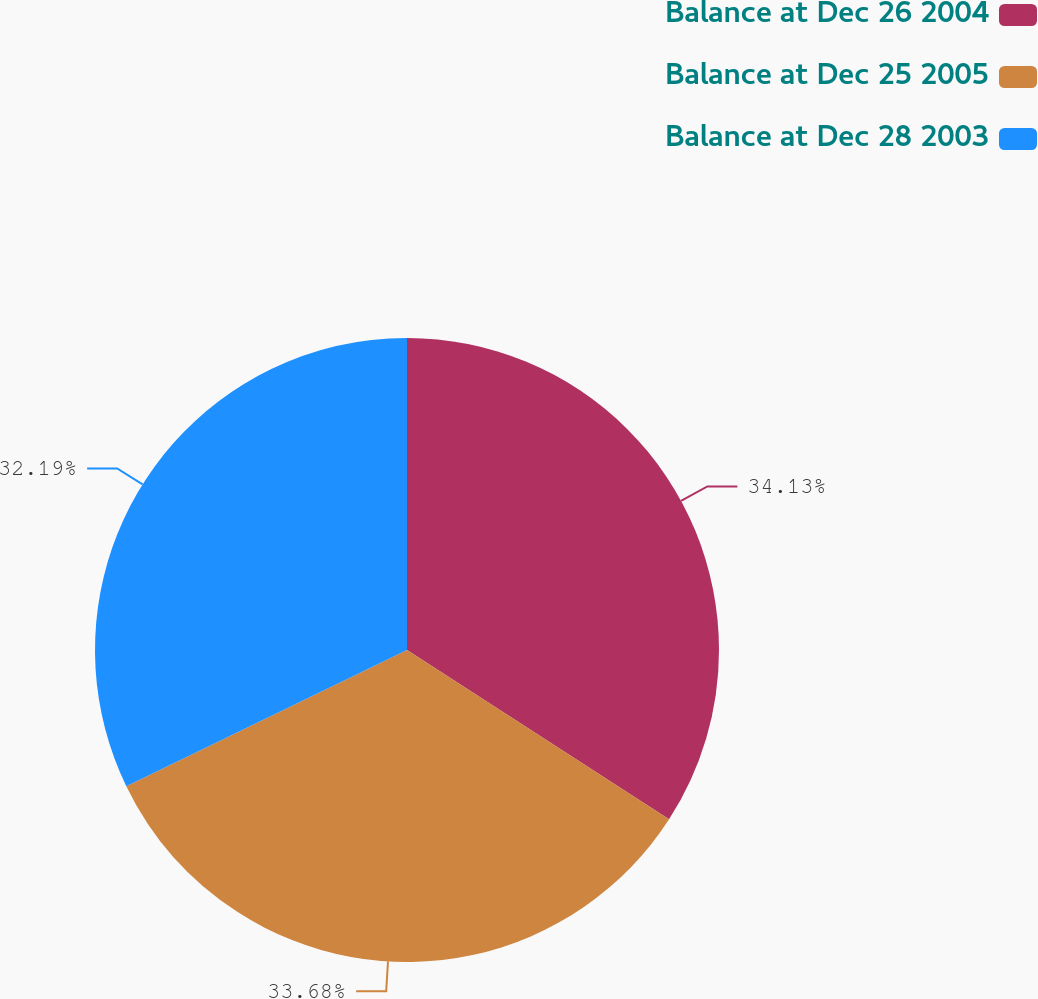Convert chart. <chart><loc_0><loc_0><loc_500><loc_500><pie_chart><fcel>Balance at Dec 26 2004<fcel>Balance at Dec 25 2005<fcel>Balance at Dec 28 2003<nl><fcel>34.13%<fcel>33.68%<fcel>32.19%<nl></chart> 